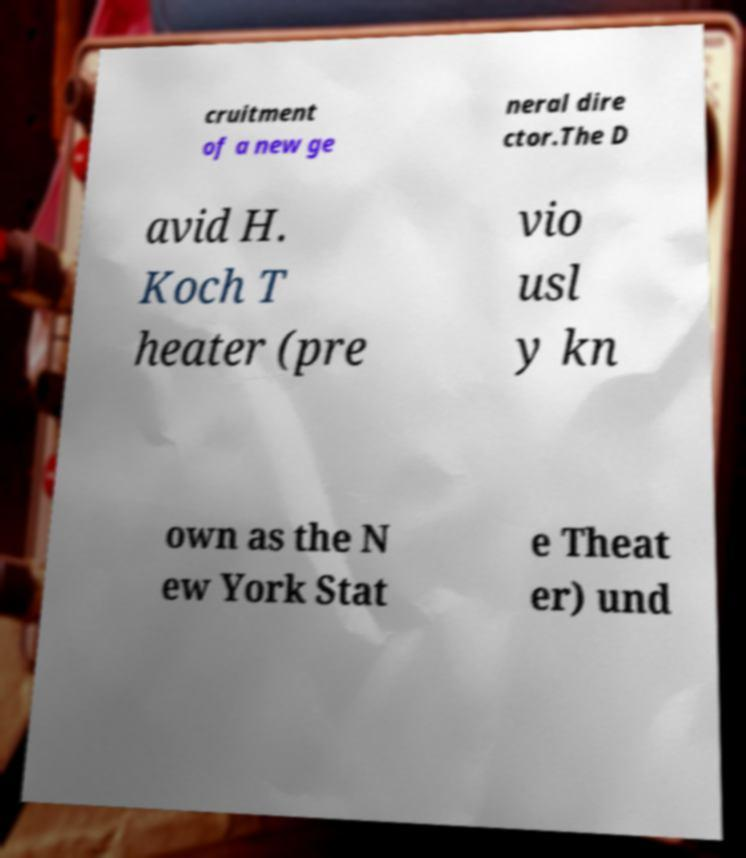There's text embedded in this image that I need extracted. Can you transcribe it verbatim? cruitment of a new ge neral dire ctor.The D avid H. Koch T heater (pre vio usl y kn own as the N ew York Stat e Theat er) und 